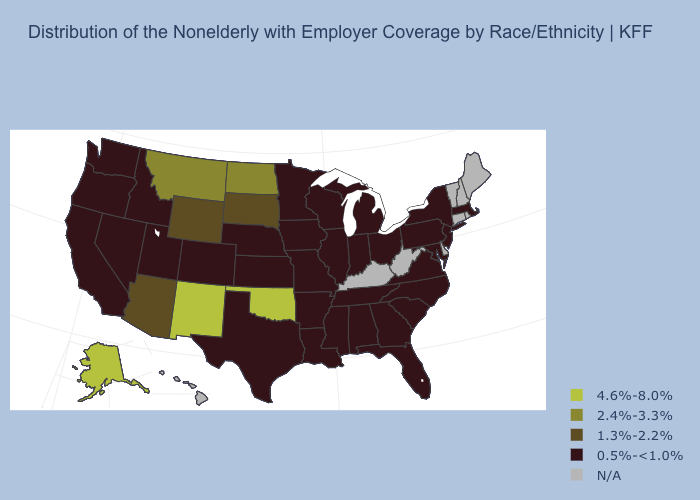Among the states that border Texas , which have the highest value?
Quick response, please. New Mexico, Oklahoma. Among the states that border Wyoming , does Montana have the highest value?
Quick response, please. Yes. What is the value of Georgia?
Quick response, please. 0.5%-<1.0%. What is the highest value in states that border Wisconsin?
Give a very brief answer. 0.5%-<1.0%. Does the first symbol in the legend represent the smallest category?
Write a very short answer. No. Name the states that have a value in the range 1.3%-2.2%?
Concise answer only. Arizona, South Dakota, Wyoming. Name the states that have a value in the range 1.3%-2.2%?
Quick response, please. Arizona, South Dakota, Wyoming. What is the value of Arkansas?
Be succinct. 0.5%-<1.0%. Name the states that have a value in the range 4.6%-8.0%?
Be succinct. Alaska, New Mexico, Oklahoma. Does Oklahoma have the lowest value in the South?
Concise answer only. No. Name the states that have a value in the range 0.5%-<1.0%?
Be succinct. Alabama, Arkansas, California, Colorado, Florida, Georgia, Idaho, Illinois, Indiana, Iowa, Kansas, Louisiana, Maryland, Massachusetts, Michigan, Minnesota, Mississippi, Missouri, Nebraska, Nevada, New Jersey, New York, North Carolina, Ohio, Oregon, Pennsylvania, South Carolina, Tennessee, Texas, Utah, Virginia, Washington, Wisconsin. Does the first symbol in the legend represent the smallest category?
Answer briefly. No. Name the states that have a value in the range N/A?
Write a very short answer. Connecticut, Delaware, Hawaii, Kentucky, Maine, New Hampshire, Rhode Island, Vermont, West Virginia. Does New Mexico have the highest value in the USA?
Quick response, please. Yes. What is the highest value in the South ?
Quick response, please. 4.6%-8.0%. 